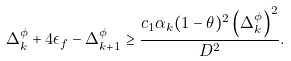<formula> <loc_0><loc_0><loc_500><loc_500>\Delta _ { k } ^ { \phi } + 4 \epsilon _ { f } - \Delta _ { k + 1 } ^ { \phi } \geq \frac { c _ { 1 } \alpha _ { k } ( 1 - \theta ) ^ { 2 } \left ( \Delta _ { k } ^ { \phi } \right ) ^ { 2 } } { D ^ { 2 } } .</formula> 